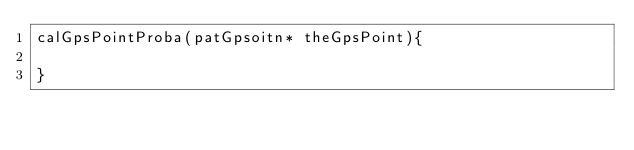Convert code to text. <code><loc_0><loc_0><loc_500><loc_500><_C++_>calGpsPointProba(patGpsoitn* theGpsPoint){
	
}</code> 